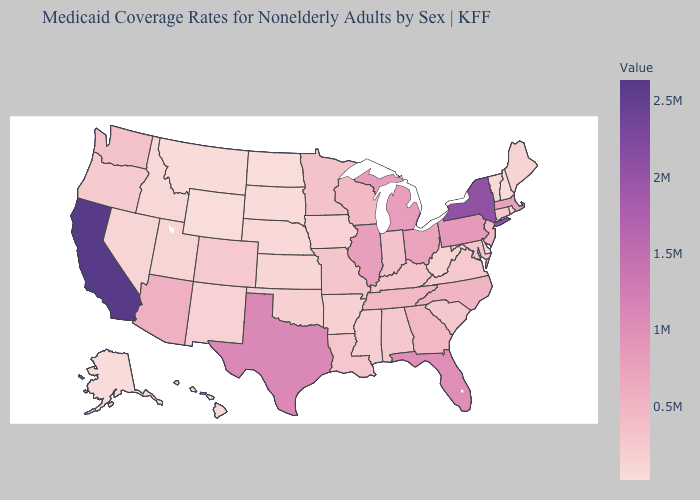Among the states that border Kansas , which have the lowest value?
Give a very brief answer. Nebraska. Which states have the lowest value in the MidWest?
Keep it brief. North Dakota. Among the states that border Nebraska , which have the lowest value?
Quick response, please. Wyoming. Which states hav the highest value in the South?
Write a very short answer. Texas. Does California have the highest value in the USA?
Give a very brief answer. Yes. Among the states that border West Virginia , which have the highest value?
Short answer required. Pennsylvania. Among the states that border Florida , which have the highest value?
Short answer required. Georgia. Among the states that border Oregon , which have the lowest value?
Concise answer only. Idaho. Does Texas have the highest value in the South?
Give a very brief answer. Yes. 